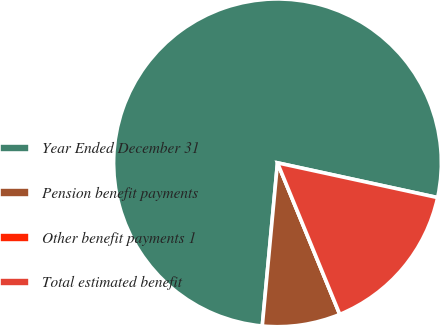<chart> <loc_0><loc_0><loc_500><loc_500><pie_chart><fcel>Year Ended December 31<fcel>Pension benefit payments<fcel>Other benefit payments 1<fcel>Total estimated benefit<nl><fcel>76.92%<fcel>7.69%<fcel>0.0%<fcel>15.39%<nl></chart> 